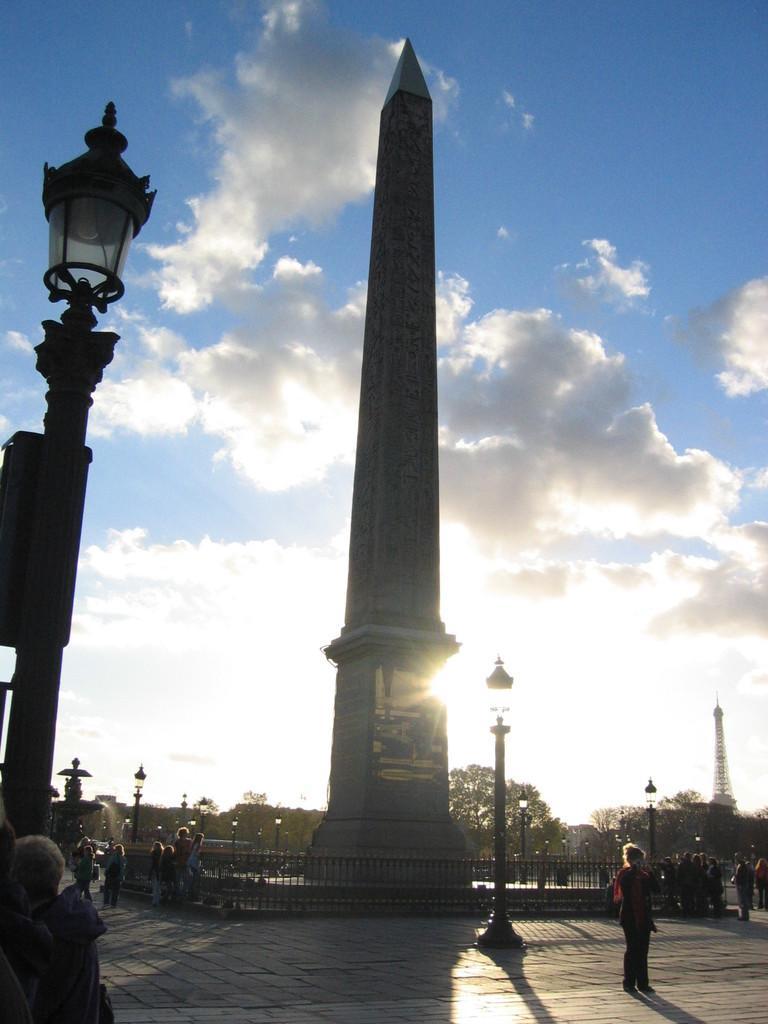How would you summarize this image in a sentence or two? There are people at the bottom of this image. We can see a pillar and trees in the background. There is a lamp on the left side of this image and the cloudy sky is in the background. 